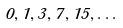Convert formula to latex. <formula><loc_0><loc_0><loc_500><loc_500>0 , 1 , 3 , 7 , 1 5 , \dots</formula> 